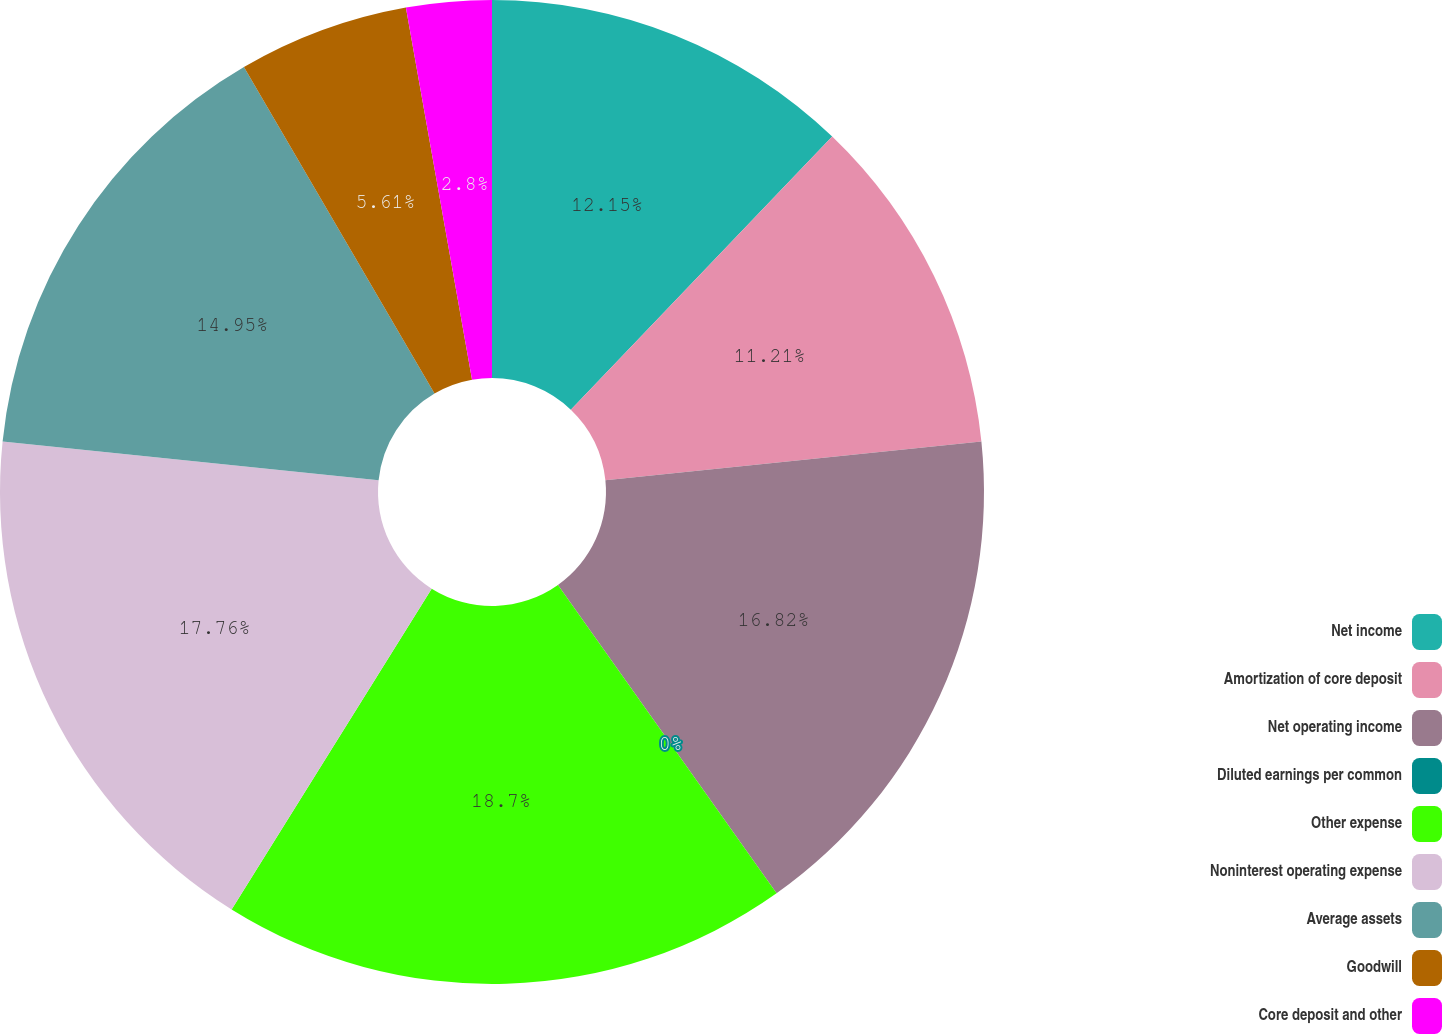Convert chart to OTSL. <chart><loc_0><loc_0><loc_500><loc_500><pie_chart><fcel>Net income<fcel>Amortization of core deposit<fcel>Net operating income<fcel>Diluted earnings per common<fcel>Other expense<fcel>Noninterest operating expense<fcel>Average assets<fcel>Goodwill<fcel>Core deposit and other<nl><fcel>12.15%<fcel>11.21%<fcel>16.82%<fcel>0.0%<fcel>18.69%<fcel>17.76%<fcel>14.95%<fcel>5.61%<fcel>2.8%<nl></chart> 